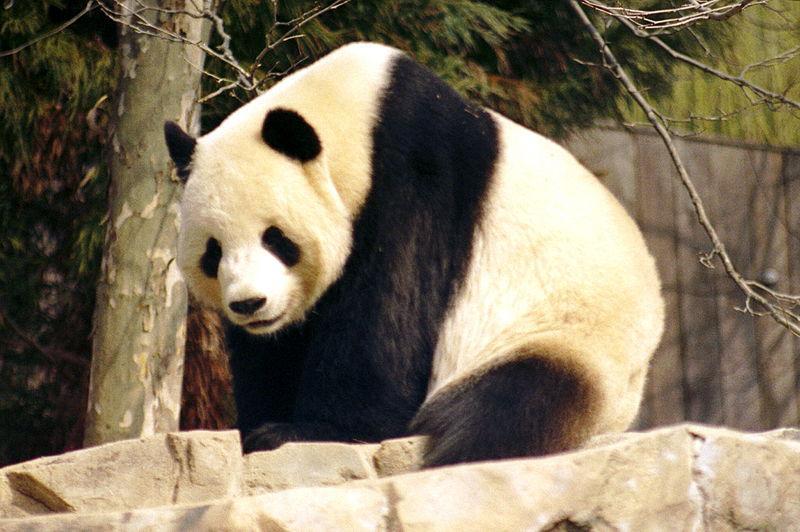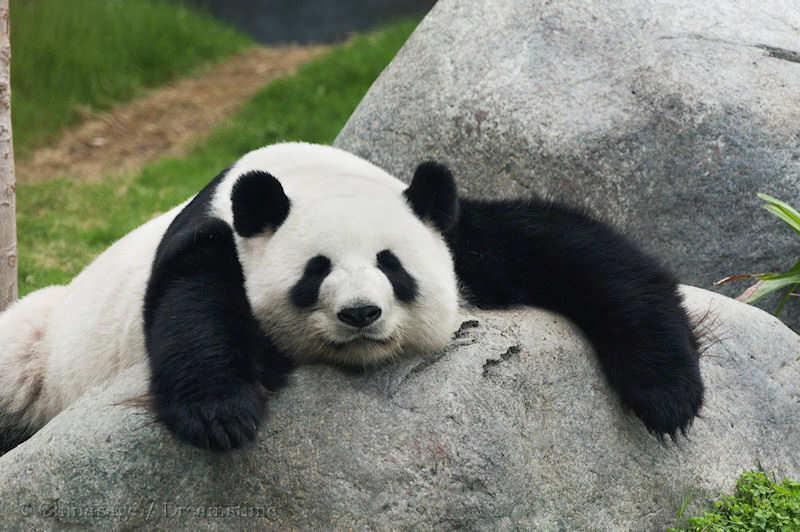The first image is the image on the left, the second image is the image on the right. Assess this claim about the two images: "One image features a baby panda next to an adult panda". Correct or not? Answer yes or no. No. 